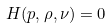Convert formula to latex. <formula><loc_0><loc_0><loc_500><loc_500>H ( p , \rho , \nu ) = 0</formula> 